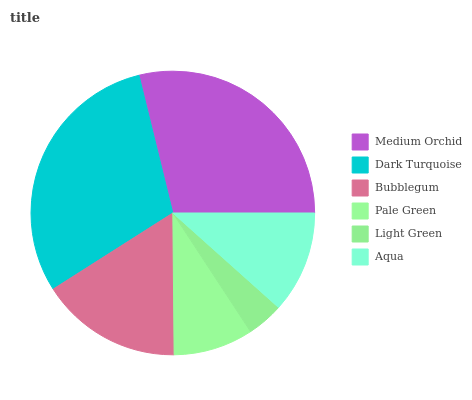Is Light Green the minimum?
Answer yes or no. Yes. Is Dark Turquoise the maximum?
Answer yes or no. Yes. Is Bubblegum the minimum?
Answer yes or no. No. Is Bubblegum the maximum?
Answer yes or no. No. Is Dark Turquoise greater than Bubblegum?
Answer yes or no. Yes. Is Bubblegum less than Dark Turquoise?
Answer yes or no. Yes. Is Bubblegum greater than Dark Turquoise?
Answer yes or no. No. Is Dark Turquoise less than Bubblegum?
Answer yes or no. No. Is Bubblegum the high median?
Answer yes or no. Yes. Is Aqua the low median?
Answer yes or no. Yes. Is Pale Green the high median?
Answer yes or no. No. Is Medium Orchid the low median?
Answer yes or no. No. 